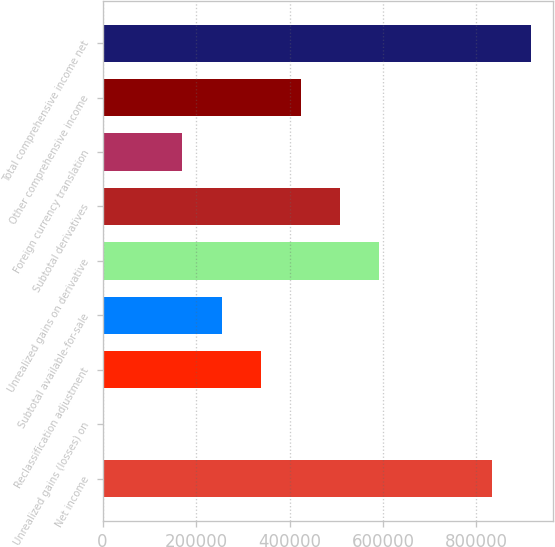Convert chart to OTSL. <chart><loc_0><loc_0><loc_500><loc_500><bar_chart><fcel>Net income<fcel>Unrealized gains (losses) on<fcel>Reclassification adjustment<fcel>Subtotal available-for-sale<fcel>Unrealized gains on derivative<fcel>Subtotal derivatives<fcel>Foreign currency translation<fcel>Other comprehensive income<fcel>Total comprehensive income net<nl><fcel>832847<fcel>1795<fcel>339225<fcel>254867<fcel>592297<fcel>507939<fcel>170510<fcel>423582<fcel>917204<nl></chart> 